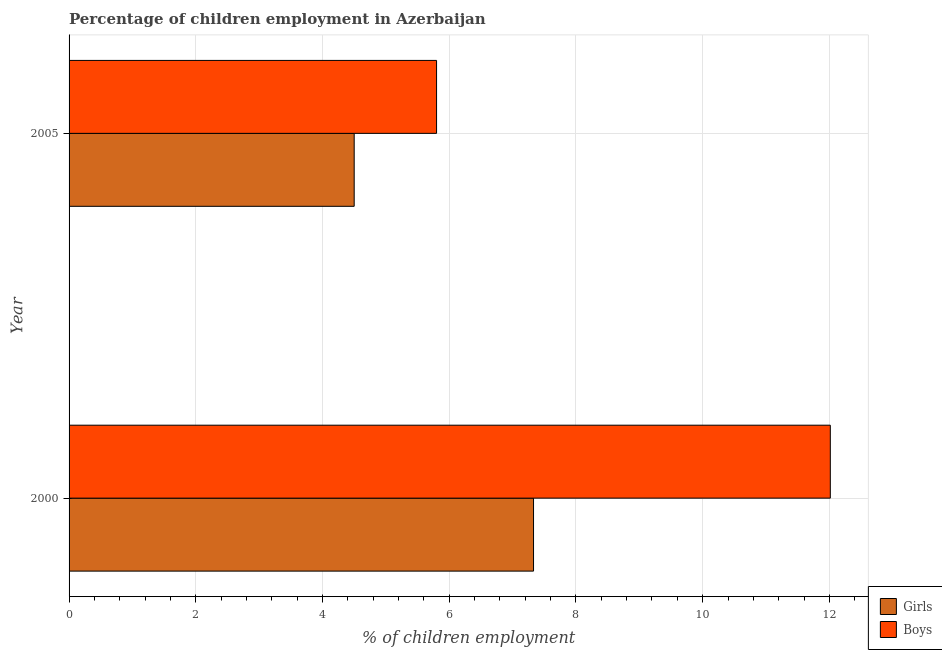Are the number of bars per tick equal to the number of legend labels?
Provide a short and direct response. Yes. Are the number of bars on each tick of the Y-axis equal?
Offer a terse response. Yes. How many bars are there on the 1st tick from the top?
Your answer should be very brief. 2. What is the label of the 2nd group of bars from the top?
Keep it short and to the point. 2000. In how many cases, is the number of bars for a given year not equal to the number of legend labels?
Make the answer very short. 0. What is the percentage of employed girls in 2000?
Offer a very short reply. 7.33. Across all years, what is the maximum percentage of employed boys?
Provide a short and direct response. 12.01. Across all years, what is the minimum percentage of employed boys?
Your answer should be very brief. 5.8. In which year was the percentage of employed girls maximum?
Make the answer very short. 2000. What is the total percentage of employed girls in the graph?
Your response must be concise. 11.83. What is the difference between the percentage of employed boys in 2000 and that in 2005?
Make the answer very short. 6.21. What is the difference between the percentage of employed boys in 2000 and the percentage of employed girls in 2005?
Ensure brevity in your answer.  7.51. What is the average percentage of employed girls per year?
Ensure brevity in your answer.  5.92. In the year 2000, what is the difference between the percentage of employed boys and percentage of employed girls?
Provide a succinct answer. 4.68. In how many years, is the percentage of employed girls greater than 10 %?
Offer a very short reply. 0. What is the ratio of the percentage of employed boys in 2000 to that in 2005?
Provide a succinct answer. 2.07. What does the 2nd bar from the top in 2000 represents?
Your answer should be compact. Girls. What does the 1st bar from the bottom in 2005 represents?
Provide a short and direct response. Girls. How many bars are there?
Your answer should be very brief. 4. Are all the bars in the graph horizontal?
Your answer should be very brief. Yes. What is the difference between two consecutive major ticks on the X-axis?
Provide a short and direct response. 2. Are the values on the major ticks of X-axis written in scientific E-notation?
Your answer should be compact. No. Where does the legend appear in the graph?
Keep it short and to the point. Bottom right. How are the legend labels stacked?
Your answer should be compact. Vertical. What is the title of the graph?
Your answer should be very brief. Percentage of children employment in Azerbaijan. What is the label or title of the X-axis?
Your answer should be compact. % of children employment. What is the label or title of the Y-axis?
Make the answer very short. Year. What is the % of children employment in Girls in 2000?
Give a very brief answer. 7.33. What is the % of children employment of Boys in 2000?
Your response must be concise. 12.01. What is the % of children employment of Girls in 2005?
Give a very brief answer. 4.5. Across all years, what is the maximum % of children employment in Girls?
Keep it short and to the point. 7.33. Across all years, what is the maximum % of children employment of Boys?
Offer a very short reply. 12.01. Across all years, what is the minimum % of children employment of Girls?
Keep it short and to the point. 4.5. Across all years, what is the minimum % of children employment in Boys?
Keep it short and to the point. 5.8. What is the total % of children employment in Girls in the graph?
Provide a short and direct response. 11.83. What is the total % of children employment of Boys in the graph?
Your answer should be compact. 17.81. What is the difference between the % of children employment in Girls in 2000 and that in 2005?
Keep it short and to the point. 2.83. What is the difference between the % of children employment in Boys in 2000 and that in 2005?
Offer a very short reply. 6.21. What is the difference between the % of children employment in Girls in 2000 and the % of children employment in Boys in 2005?
Your answer should be very brief. 1.53. What is the average % of children employment of Girls per year?
Your answer should be compact. 5.92. What is the average % of children employment in Boys per year?
Make the answer very short. 8.91. In the year 2000, what is the difference between the % of children employment in Girls and % of children employment in Boys?
Give a very brief answer. -4.68. What is the ratio of the % of children employment of Girls in 2000 to that in 2005?
Your response must be concise. 1.63. What is the ratio of the % of children employment of Boys in 2000 to that in 2005?
Keep it short and to the point. 2.07. What is the difference between the highest and the second highest % of children employment in Girls?
Ensure brevity in your answer.  2.83. What is the difference between the highest and the second highest % of children employment of Boys?
Your answer should be compact. 6.21. What is the difference between the highest and the lowest % of children employment of Girls?
Offer a very short reply. 2.83. What is the difference between the highest and the lowest % of children employment in Boys?
Offer a terse response. 6.21. 